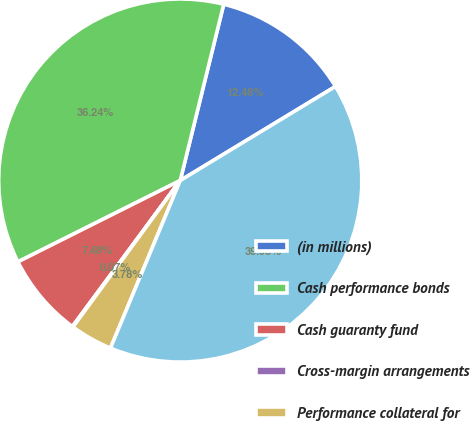Convert chart to OTSL. <chart><loc_0><loc_0><loc_500><loc_500><pie_chart><fcel>(in millions)<fcel>Cash performance bonds<fcel>Cash guaranty fund<fcel>Cross-margin arrangements<fcel>Performance collateral for<fcel>Total<nl><fcel>12.48%<fcel>36.24%<fcel>7.48%<fcel>0.07%<fcel>3.78%<fcel>39.95%<nl></chart> 